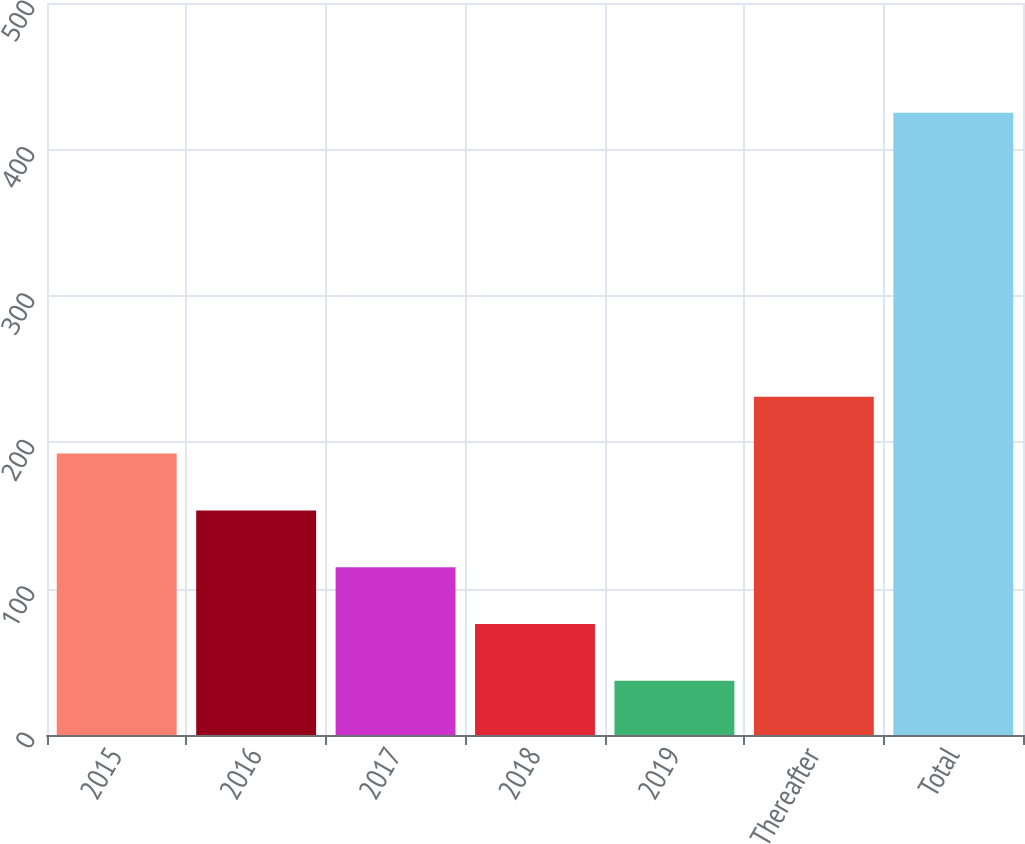<chart> <loc_0><loc_0><loc_500><loc_500><bar_chart><fcel>2015<fcel>2016<fcel>2017<fcel>2018<fcel>2019<fcel>Thereafter<fcel>Total<nl><fcel>192.2<fcel>153.4<fcel>114.6<fcel>75.8<fcel>37<fcel>231<fcel>425<nl></chart> 